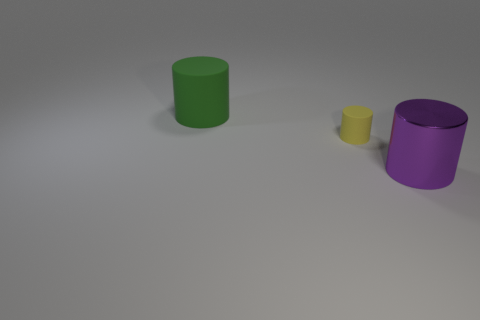What is the color of the tiny object that is the same material as the large green cylinder?
Provide a succinct answer. Yellow. What number of other matte things have the same size as the purple object?
Your answer should be compact. 1. What number of purple objects are either cylinders or tiny objects?
Give a very brief answer. 1. How many objects are either tiny green objects or large objects that are on the left side of the shiny cylinder?
Provide a short and direct response. 1. What is the material of the large thing that is to the left of the big purple object?
Offer a very short reply. Rubber. There is a purple metal thing that is the same size as the green rubber thing; what shape is it?
Make the answer very short. Cylinder. Are there any tiny yellow objects of the same shape as the big purple shiny object?
Offer a very short reply. Yes. Is the material of the yellow thing the same as the cylinder that is behind the tiny yellow matte object?
Your answer should be compact. Yes. There is a tiny yellow thing that is in front of the big cylinder that is behind the big purple shiny object; what is it made of?
Your response must be concise. Rubber. Is the number of rubber cylinders that are to the right of the green rubber cylinder greater than the number of large gray rubber objects?
Ensure brevity in your answer.  Yes. 